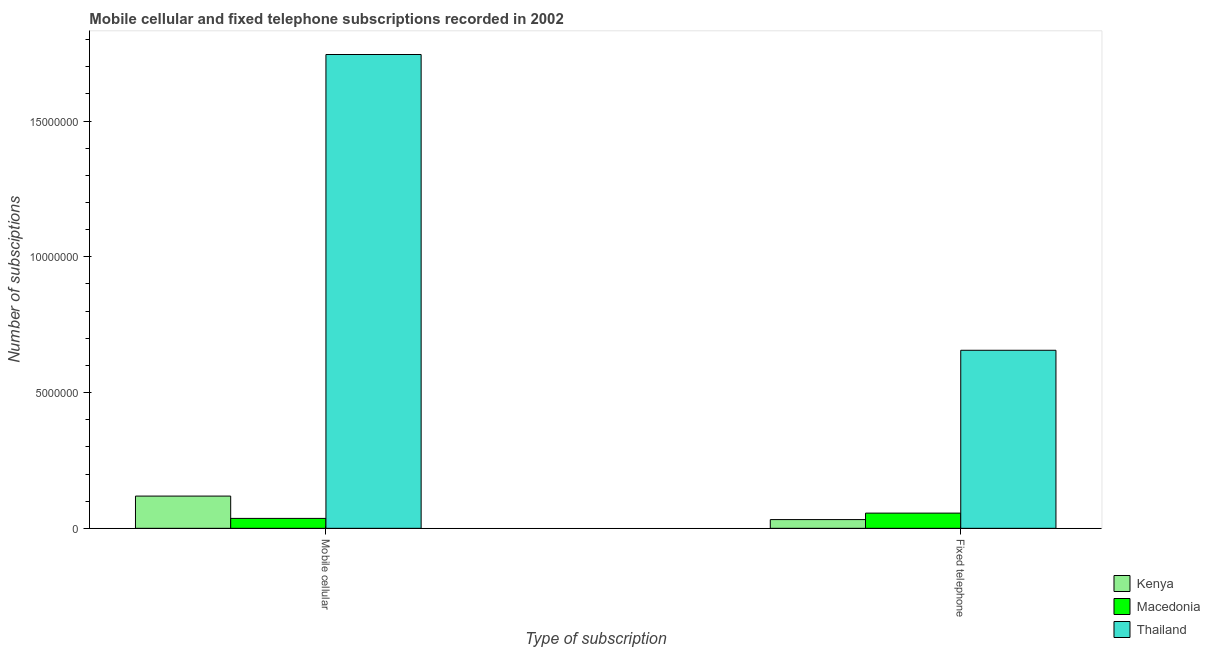How many different coloured bars are there?
Offer a very short reply. 3. Are the number of bars per tick equal to the number of legend labels?
Your answer should be very brief. Yes. What is the label of the 2nd group of bars from the left?
Your answer should be compact. Fixed telephone. What is the number of mobile cellular subscriptions in Kenya?
Make the answer very short. 1.19e+06. Across all countries, what is the maximum number of mobile cellular subscriptions?
Keep it short and to the point. 1.74e+07. Across all countries, what is the minimum number of fixed telephone subscriptions?
Offer a very short reply. 3.21e+05. In which country was the number of fixed telephone subscriptions maximum?
Your answer should be very brief. Thailand. In which country was the number of mobile cellular subscriptions minimum?
Your response must be concise. Macedonia. What is the total number of mobile cellular subscriptions in the graph?
Your answer should be very brief. 1.90e+07. What is the difference between the number of mobile cellular subscriptions in Kenya and that in Thailand?
Your response must be concise. -1.63e+07. What is the difference between the number of fixed telephone subscriptions in Macedonia and the number of mobile cellular subscriptions in Kenya?
Keep it short and to the point. -6.27e+05. What is the average number of fixed telephone subscriptions per country?
Keep it short and to the point. 2.48e+06. What is the difference between the number of fixed telephone subscriptions and number of mobile cellular subscriptions in Macedonia?
Your response must be concise. 1.95e+05. What is the ratio of the number of fixed telephone subscriptions in Macedonia to that in Thailand?
Provide a short and direct response. 0.09. What does the 3rd bar from the left in Fixed telephone represents?
Your answer should be very brief. Thailand. What does the 2nd bar from the right in Mobile cellular represents?
Offer a very short reply. Macedonia. How many bars are there?
Give a very brief answer. 6. Are all the bars in the graph horizontal?
Provide a succinct answer. No. Are the values on the major ticks of Y-axis written in scientific E-notation?
Provide a succinct answer. No. How many legend labels are there?
Offer a very short reply. 3. How are the legend labels stacked?
Ensure brevity in your answer.  Vertical. What is the title of the graph?
Keep it short and to the point. Mobile cellular and fixed telephone subscriptions recorded in 2002. What is the label or title of the X-axis?
Make the answer very short. Type of subscription. What is the label or title of the Y-axis?
Your response must be concise. Number of subsciptions. What is the Number of subsciptions in Kenya in Mobile cellular?
Ensure brevity in your answer.  1.19e+06. What is the Number of subsciptions in Macedonia in Mobile cellular?
Provide a succinct answer. 3.65e+05. What is the Number of subsciptions of Thailand in Mobile cellular?
Your answer should be very brief. 1.74e+07. What is the Number of subsciptions of Kenya in Fixed telephone?
Make the answer very short. 3.21e+05. What is the Number of subsciptions in Macedonia in Fixed telephone?
Keep it short and to the point. 5.60e+05. What is the Number of subsciptions in Thailand in Fixed telephone?
Keep it short and to the point. 6.56e+06. Across all Type of subscription, what is the maximum Number of subsciptions in Kenya?
Make the answer very short. 1.19e+06. Across all Type of subscription, what is the maximum Number of subsciptions in Macedonia?
Ensure brevity in your answer.  5.60e+05. Across all Type of subscription, what is the maximum Number of subsciptions of Thailand?
Your answer should be compact. 1.74e+07. Across all Type of subscription, what is the minimum Number of subsciptions of Kenya?
Your response must be concise. 3.21e+05. Across all Type of subscription, what is the minimum Number of subsciptions of Macedonia?
Give a very brief answer. 3.65e+05. Across all Type of subscription, what is the minimum Number of subsciptions in Thailand?
Your answer should be compact. 6.56e+06. What is the total Number of subsciptions in Kenya in the graph?
Your answer should be very brief. 1.51e+06. What is the total Number of subsciptions of Macedonia in the graph?
Provide a succinct answer. 9.25e+05. What is the total Number of subsciptions in Thailand in the graph?
Your response must be concise. 2.40e+07. What is the difference between the Number of subsciptions of Kenya in Mobile cellular and that in Fixed telephone?
Provide a short and direct response. 8.66e+05. What is the difference between the Number of subsciptions of Macedonia in Mobile cellular and that in Fixed telephone?
Provide a short and direct response. -1.95e+05. What is the difference between the Number of subsciptions in Thailand in Mobile cellular and that in Fixed telephone?
Provide a succinct answer. 1.09e+07. What is the difference between the Number of subsciptions in Kenya in Mobile cellular and the Number of subsciptions in Macedonia in Fixed telephone?
Provide a short and direct response. 6.27e+05. What is the difference between the Number of subsciptions in Kenya in Mobile cellular and the Number of subsciptions in Thailand in Fixed telephone?
Provide a succinct answer. -5.37e+06. What is the difference between the Number of subsciptions of Macedonia in Mobile cellular and the Number of subsciptions of Thailand in Fixed telephone?
Ensure brevity in your answer.  -6.19e+06. What is the average Number of subsciptions of Kenya per Type of subscription?
Your answer should be compact. 7.54e+05. What is the average Number of subsciptions in Macedonia per Type of subscription?
Give a very brief answer. 4.63e+05. What is the average Number of subsciptions in Thailand per Type of subscription?
Your answer should be very brief. 1.20e+07. What is the difference between the Number of subsciptions in Kenya and Number of subsciptions in Macedonia in Mobile cellular?
Your answer should be very brief. 8.22e+05. What is the difference between the Number of subsciptions of Kenya and Number of subsciptions of Thailand in Mobile cellular?
Ensure brevity in your answer.  -1.63e+07. What is the difference between the Number of subsciptions in Macedonia and Number of subsciptions in Thailand in Mobile cellular?
Give a very brief answer. -1.71e+07. What is the difference between the Number of subsciptions of Kenya and Number of subsciptions of Macedonia in Fixed telephone?
Your answer should be very brief. -2.39e+05. What is the difference between the Number of subsciptions of Kenya and Number of subsciptions of Thailand in Fixed telephone?
Offer a very short reply. -6.24e+06. What is the difference between the Number of subsciptions of Macedonia and Number of subsciptions of Thailand in Fixed telephone?
Your answer should be very brief. -6.00e+06. What is the ratio of the Number of subsciptions in Kenya in Mobile cellular to that in Fixed telephone?
Keep it short and to the point. 3.69. What is the ratio of the Number of subsciptions of Macedonia in Mobile cellular to that in Fixed telephone?
Offer a very short reply. 0.65. What is the ratio of the Number of subsciptions in Thailand in Mobile cellular to that in Fixed telephone?
Make the answer very short. 2.66. What is the difference between the highest and the second highest Number of subsciptions in Kenya?
Keep it short and to the point. 8.66e+05. What is the difference between the highest and the second highest Number of subsciptions in Macedonia?
Provide a short and direct response. 1.95e+05. What is the difference between the highest and the second highest Number of subsciptions of Thailand?
Give a very brief answer. 1.09e+07. What is the difference between the highest and the lowest Number of subsciptions in Kenya?
Your answer should be very brief. 8.66e+05. What is the difference between the highest and the lowest Number of subsciptions of Macedonia?
Ensure brevity in your answer.  1.95e+05. What is the difference between the highest and the lowest Number of subsciptions of Thailand?
Give a very brief answer. 1.09e+07. 